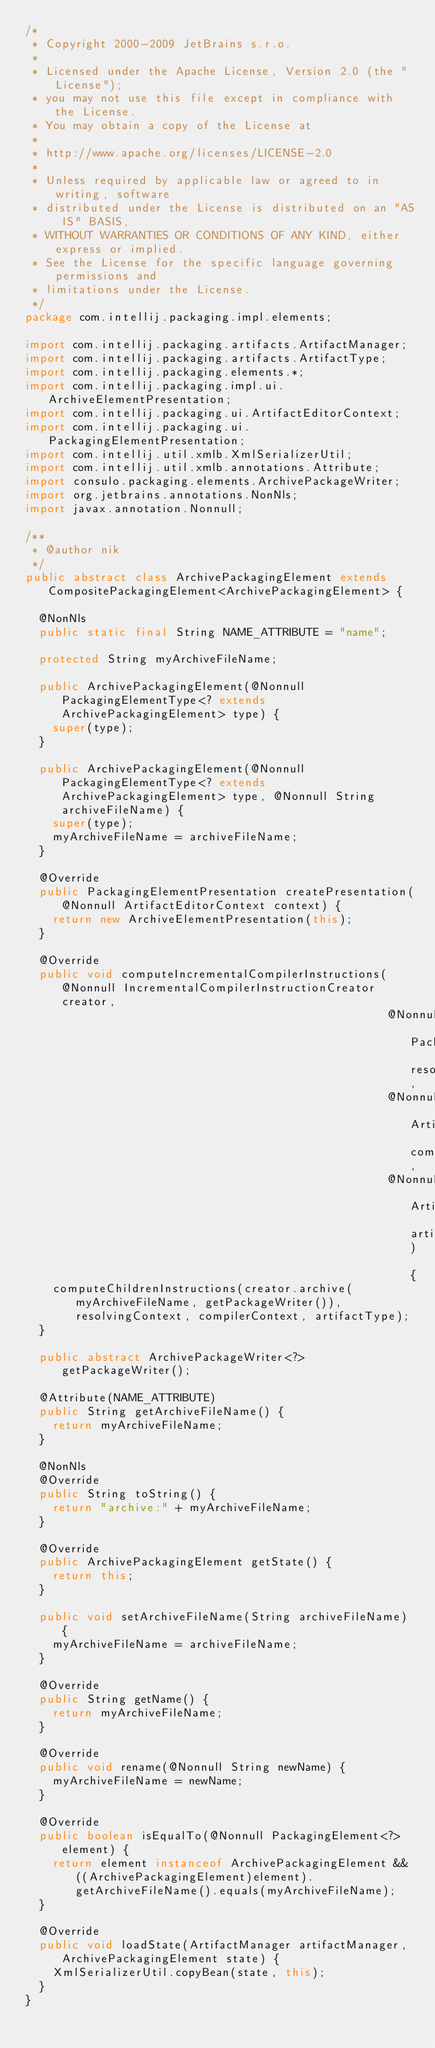Convert code to text. <code><loc_0><loc_0><loc_500><loc_500><_Java_>/*
 * Copyright 2000-2009 JetBrains s.r.o.
 *
 * Licensed under the Apache License, Version 2.0 (the "License");
 * you may not use this file except in compliance with the License.
 * You may obtain a copy of the License at
 *
 * http://www.apache.org/licenses/LICENSE-2.0
 *
 * Unless required by applicable law or agreed to in writing, software
 * distributed under the License is distributed on an "AS IS" BASIS,
 * WITHOUT WARRANTIES OR CONDITIONS OF ANY KIND, either express or implied.
 * See the License for the specific language governing permissions and
 * limitations under the License.
 */
package com.intellij.packaging.impl.elements;

import com.intellij.packaging.artifacts.ArtifactManager;
import com.intellij.packaging.artifacts.ArtifactType;
import com.intellij.packaging.elements.*;
import com.intellij.packaging.impl.ui.ArchiveElementPresentation;
import com.intellij.packaging.ui.ArtifactEditorContext;
import com.intellij.packaging.ui.PackagingElementPresentation;
import com.intellij.util.xmlb.XmlSerializerUtil;
import com.intellij.util.xmlb.annotations.Attribute;
import consulo.packaging.elements.ArchivePackageWriter;
import org.jetbrains.annotations.NonNls;
import javax.annotation.Nonnull;

/**
 * @author nik
 */
public abstract class ArchivePackagingElement extends CompositePackagingElement<ArchivePackagingElement> {

  @NonNls
  public static final String NAME_ATTRIBUTE = "name";

  protected String myArchiveFileName;

  public ArchivePackagingElement(@Nonnull PackagingElementType<? extends ArchivePackagingElement> type) {
    super(type);
  }

  public ArchivePackagingElement(@Nonnull PackagingElementType<? extends ArchivePackagingElement> type, @Nonnull String archiveFileName) {
    super(type);
    myArchiveFileName = archiveFileName;
  }

  @Override
  public PackagingElementPresentation createPresentation(@Nonnull ArtifactEditorContext context) {
    return new ArchiveElementPresentation(this);
  }

  @Override
  public void computeIncrementalCompilerInstructions(@Nonnull IncrementalCompilerInstructionCreator creator,
                                                     @Nonnull PackagingElementResolvingContext resolvingContext,
                                                     @Nonnull ArtifactIncrementalCompilerContext compilerContext,
                                                     @Nonnull ArtifactType artifactType) {
    computeChildrenInstructions(creator.archive(myArchiveFileName, getPackageWriter()), resolvingContext, compilerContext, artifactType);
  }

  public abstract ArchivePackageWriter<?> getPackageWriter();

  @Attribute(NAME_ATTRIBUTE)
  public String getArchiveFileName() {
    return myArchiveFileName;
  }

  @NonNls
  @Override
  public String toString() {
    return "archive:" + myArchiveFileName;
  }

  @Override
  public ArchivePackagingElement getState() {
    return this;
  }

  public void setArchiveFileName(String archiveFileName) {
    myArchiveFileName = archiveFileName;
  }

  @Override
  public String getName() {
    return myArchiveFileName;
  }

  @Override
  public void rename(@Nonnull String newName) {
    myArchiveFileName = newName;
  }

  @Override
  public boolean isEqualTo(@Nonnull PackagingElement<?> element) {
    return element instanceof ArchivePackagingElement && ((ArchivePackagingElement)element).getArchiveFileName().equals(myArchiveFileName);
  }

  @Override
  public void loadState(ArtifactManager artifactManager, ArchivePackagingElement state) {
    XmlSerializerUtil.copyBean(state, this);
  }
}
</code> 